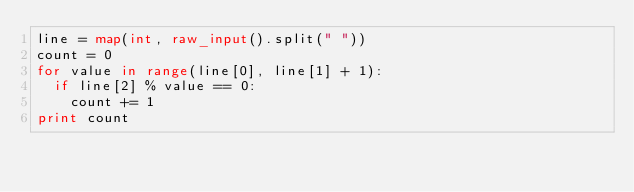Convert code to text. <code><loc_0><loc_0><loc_500><loc_500><_Python_>line = map(int, raw_input().split(" "))
count = 0
for value in range(line[0], line[1] + 1):
  if line[2] % value == 0:
    count += 1
print count</code> 